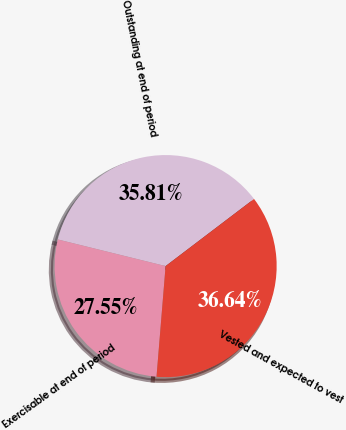<chart> <loc_0><loc_0><loc_500><loc_500><pie_chart><fcel>Outstanding at end of period<fcel>Exercisable at end of period<fcel>Vested and expected to vest<nl><fcel>35.81%<fcel>27.55%<fcel>36.64%<nl></chart> 